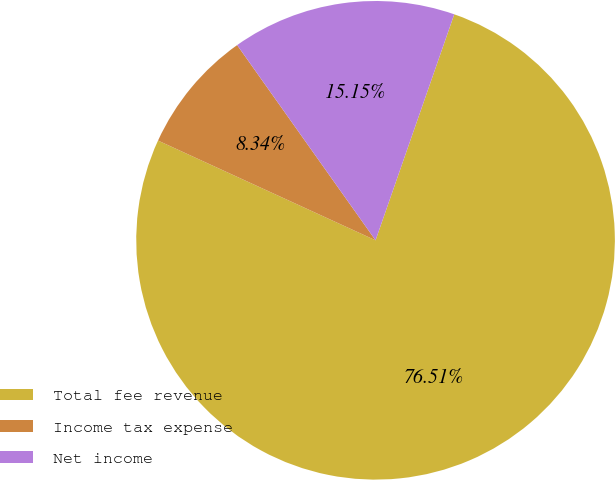Convert chart. <chart><loc_0><loc_0><loc_500><loc_500><pie_chart><fcel>Total fee revenue<fcel>Income tax expense<fcel>Net income<nl><fcel>76.51%<fcel>8.34%<fcel>15.15%<nl></chart> 